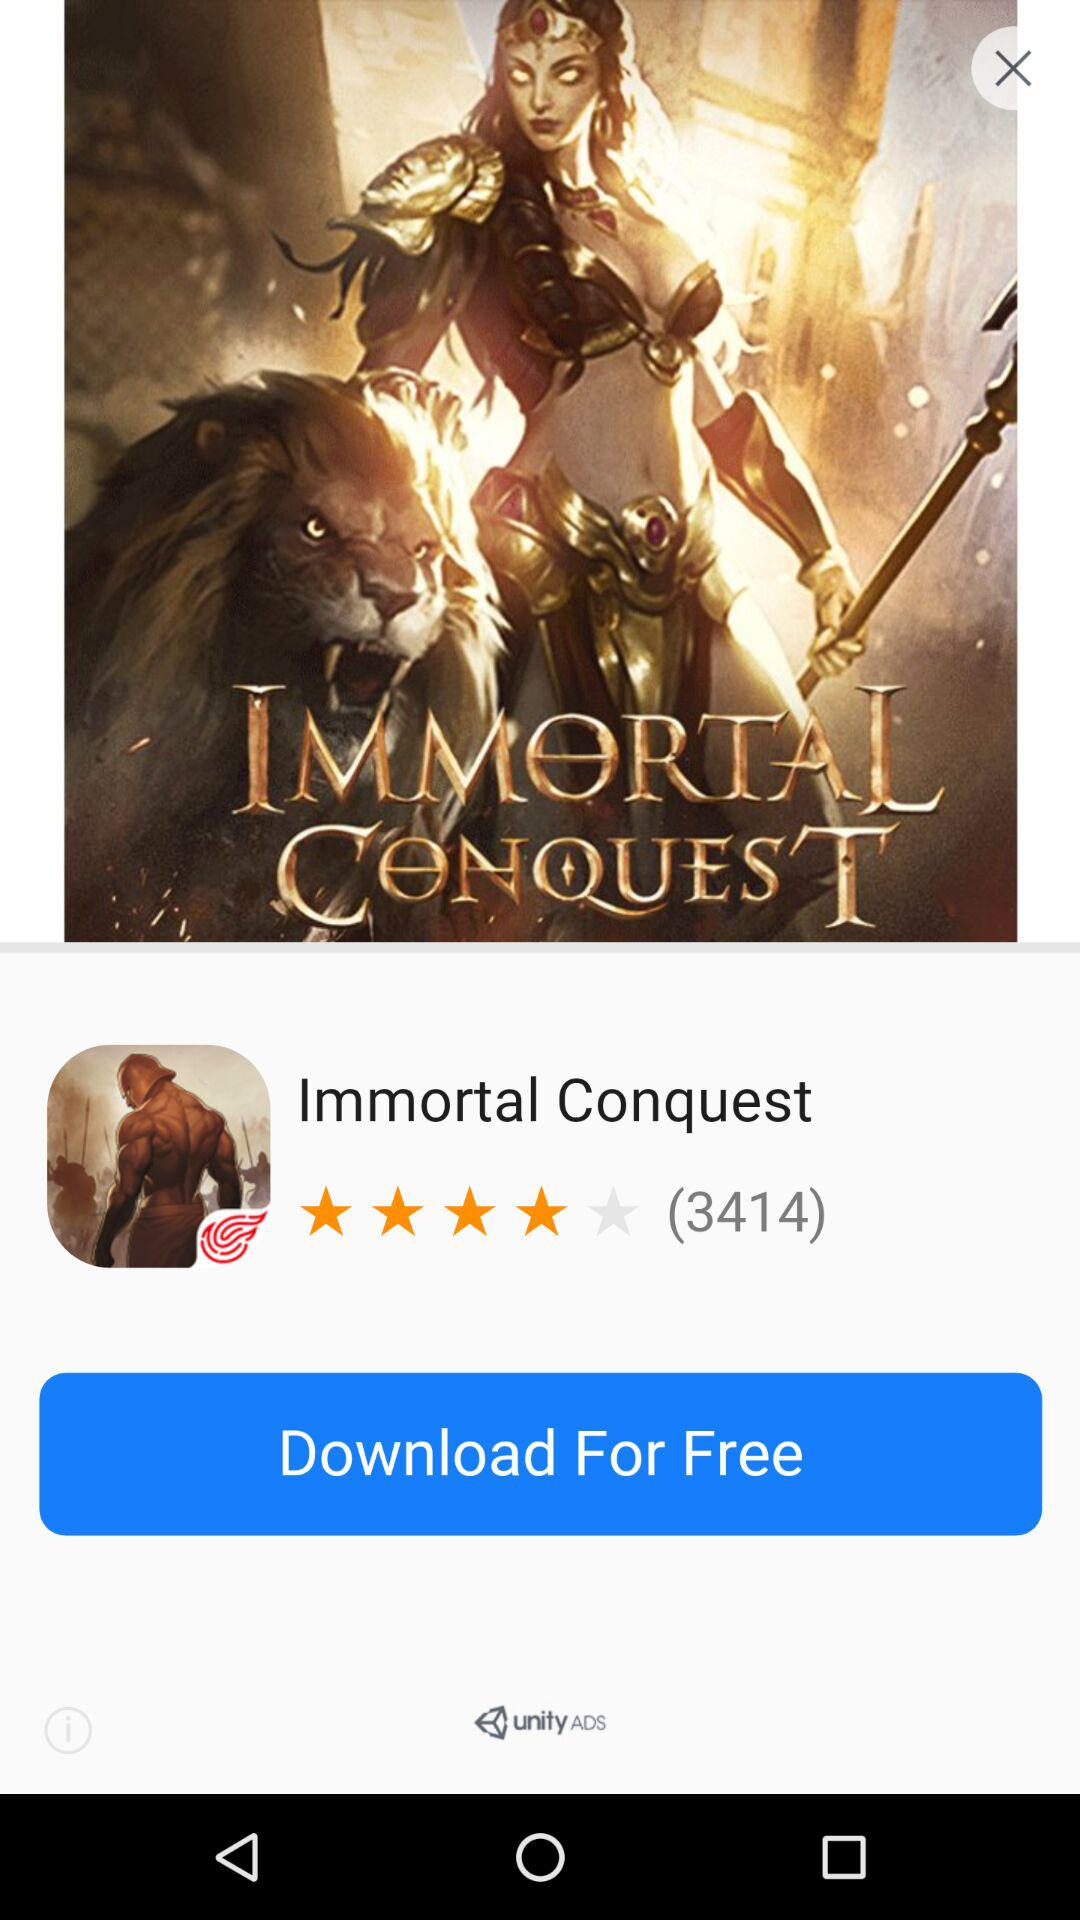By how many people is the Immortal Conquest reviewed? There are 3414 who reviewed the Immortal Conquest. 